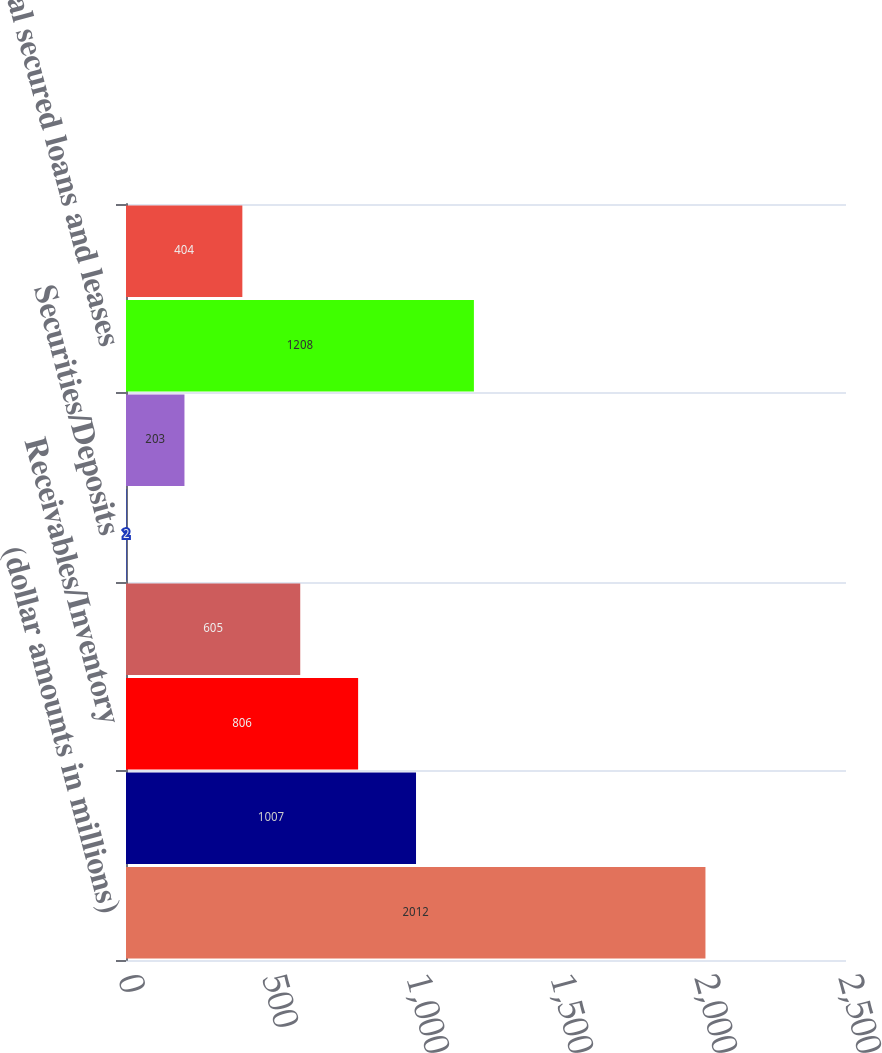<chart> <loc_0><loc_0><loc_500><loc_500><bar_chart><fcel>(dollar amounts in millions)<fcel>Vehicles<fcel>Receivables/Inventory<fcel>Machinery/Equipment<fcel>Securities/Deposits<fcel>Other<fcel>Total secured loans and leases<fcel>Unsecured loans and leases<nl><fcel>2012<fcel>1007<fcel>806<fcel>605<fcel>2<fcel>203<fcel>1208<fcel>404<nl></chart> 